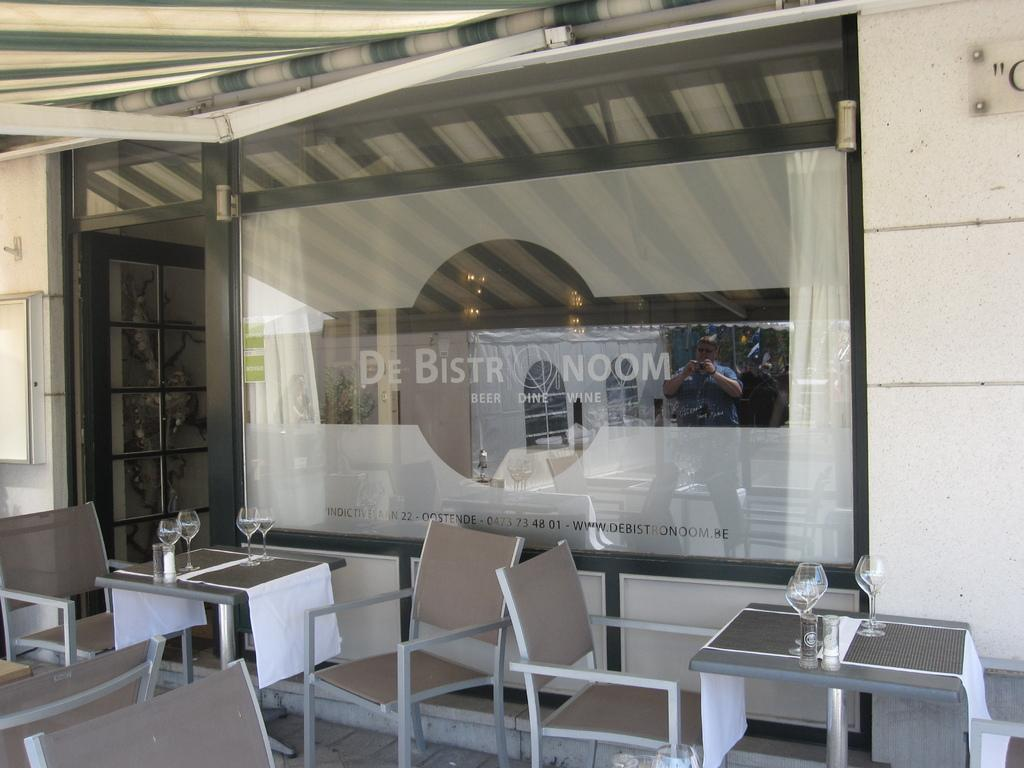Provide a one-sentence caption for the provided image. Empty tables are ready for customers outside of De Bistro Noom beer dine and wine. 